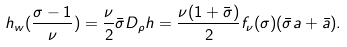Convert formula to latex. <formula><loc_0><loc_0><loc_500><loc_500>h _ { w } ( \frac { \sigma - 1 } { \nu } ) = \frac { \nu } { 2 } \bar { \sigma } D _ { \rho } h = \frac { \nu ( 1 + \bar { \sigma } ) } { 2 } f _ { \nu } ( \sigma ) ( \bar { \sigma } a + \bar { a } ) .</formula> 